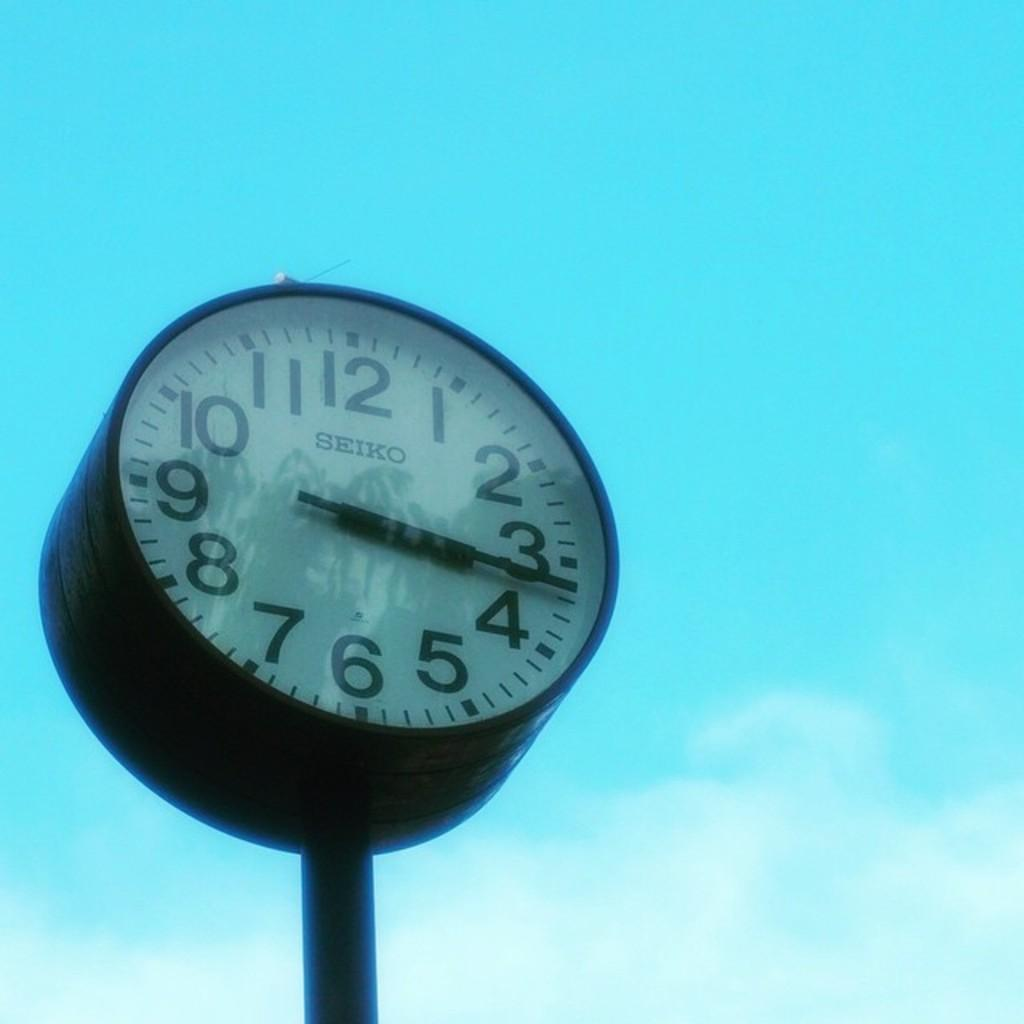What object in the image can be used to tell time? There is a clock in the image that can be used to tell time. What can be seen in the background of the image? The sky is visible in the background of the image. Can you describe the horse in the image? There is no horse present in the image. What type of lamp is used to illuminate the clock in the image? There is no lamp present in the image; the clock is visible in the context of the sky. 